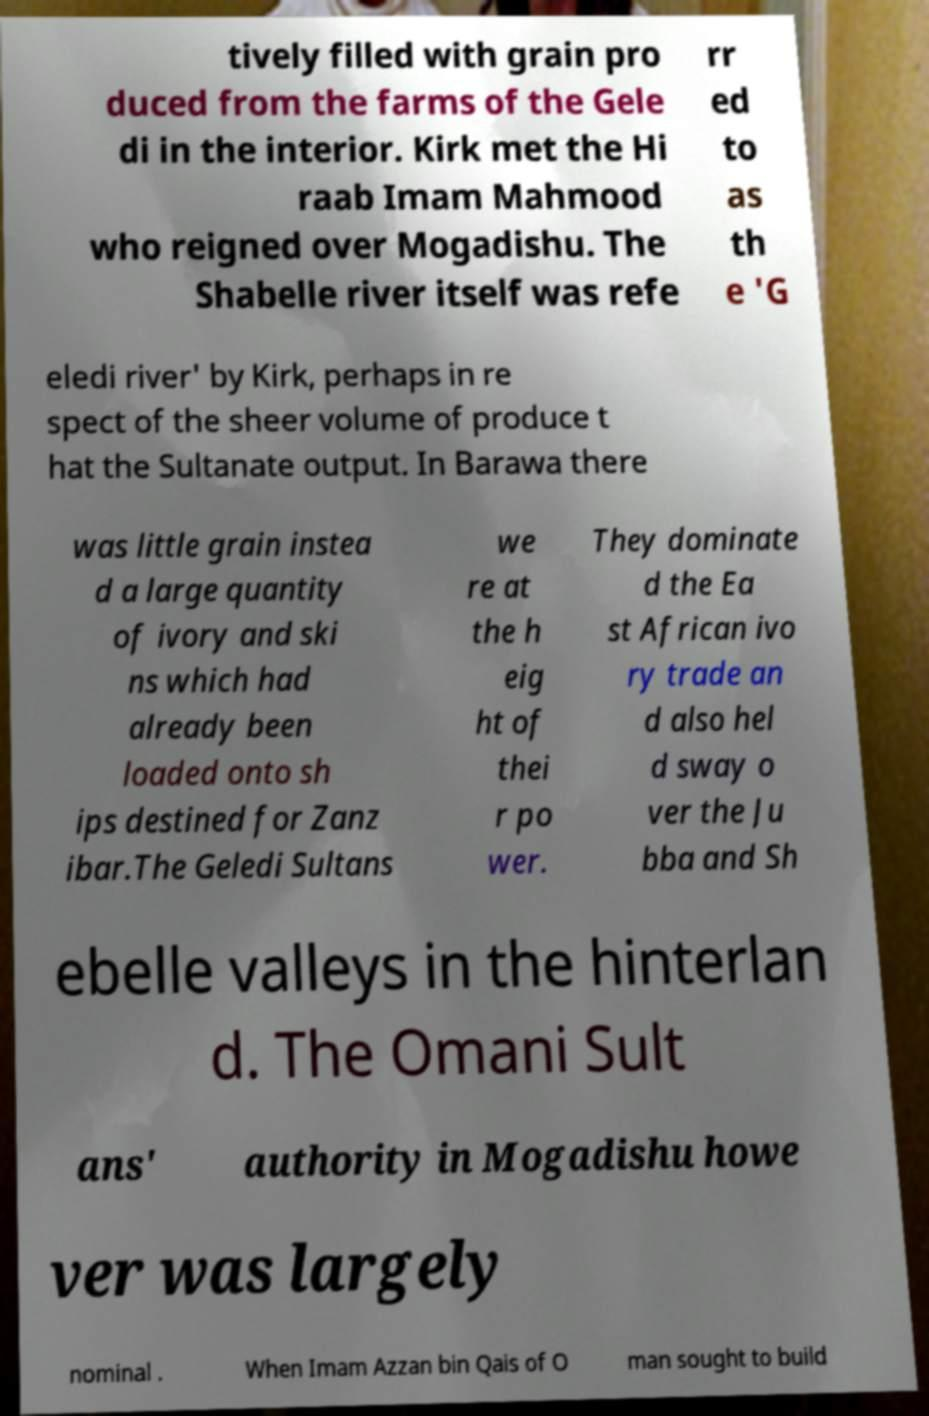There's text embedded in this image that I need extracted. Can you transcribe it verbatim? tively filled with grain pro duced from the farms of the Gele di in the interior. Kirk met the Hi raab Imam Mahmood who reigned over Mogadishu. The Shabelle river itself was refe rr ed to as th e 'G eledi river' by Kirk, perhaps in re spect of the sheer volume of produce t hat the Sultanate output. In Barawa there was little grain instea d a large quantity of ivory and ski ns which had already been loaded onto sh ips destined for Zanz ibar.The Geledi Sultans we re at the h eig ht of thei r po wer. They dominate d the Ea st African ivo ry trade an d also hel d sway o ver the Ju bba and Sh ebelle valleys in the hinterlan d. The Omani Sult ans' authority in Mogadishu howe ver was largely nominal . When Imam Azzan bin Qais of O man sought to build 